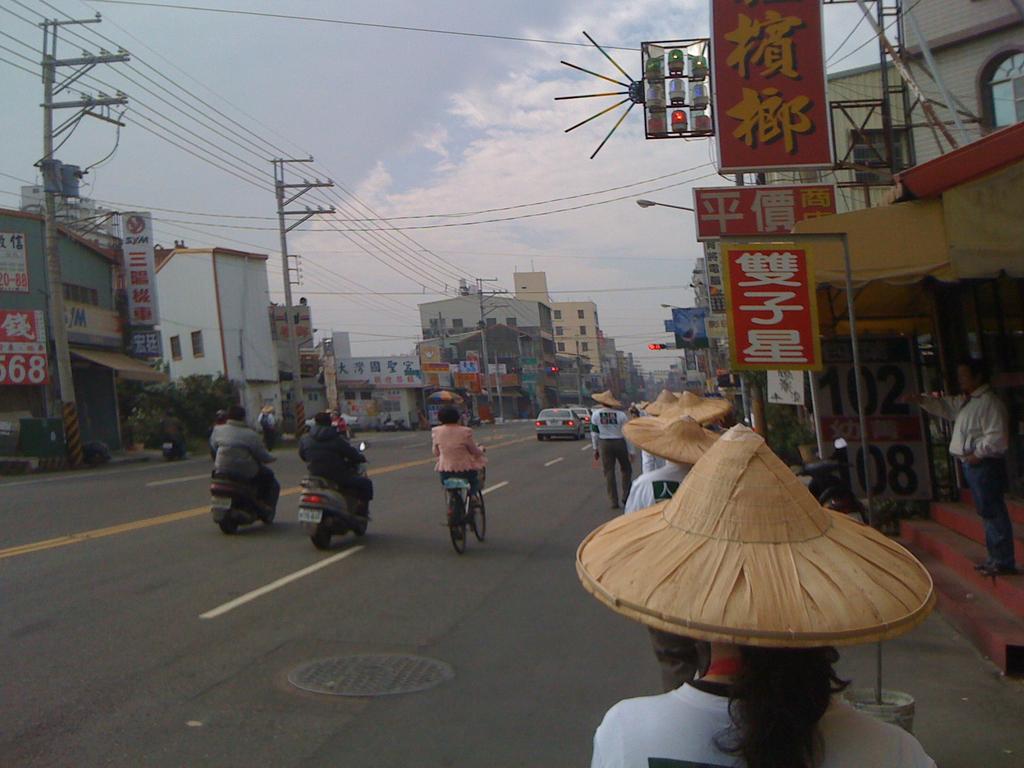What number is listed in black on the sidewalk?
Provide a succinct answer. 108. What number can be see on the red and white sign on the left?
Offer a very short reply. 68. 